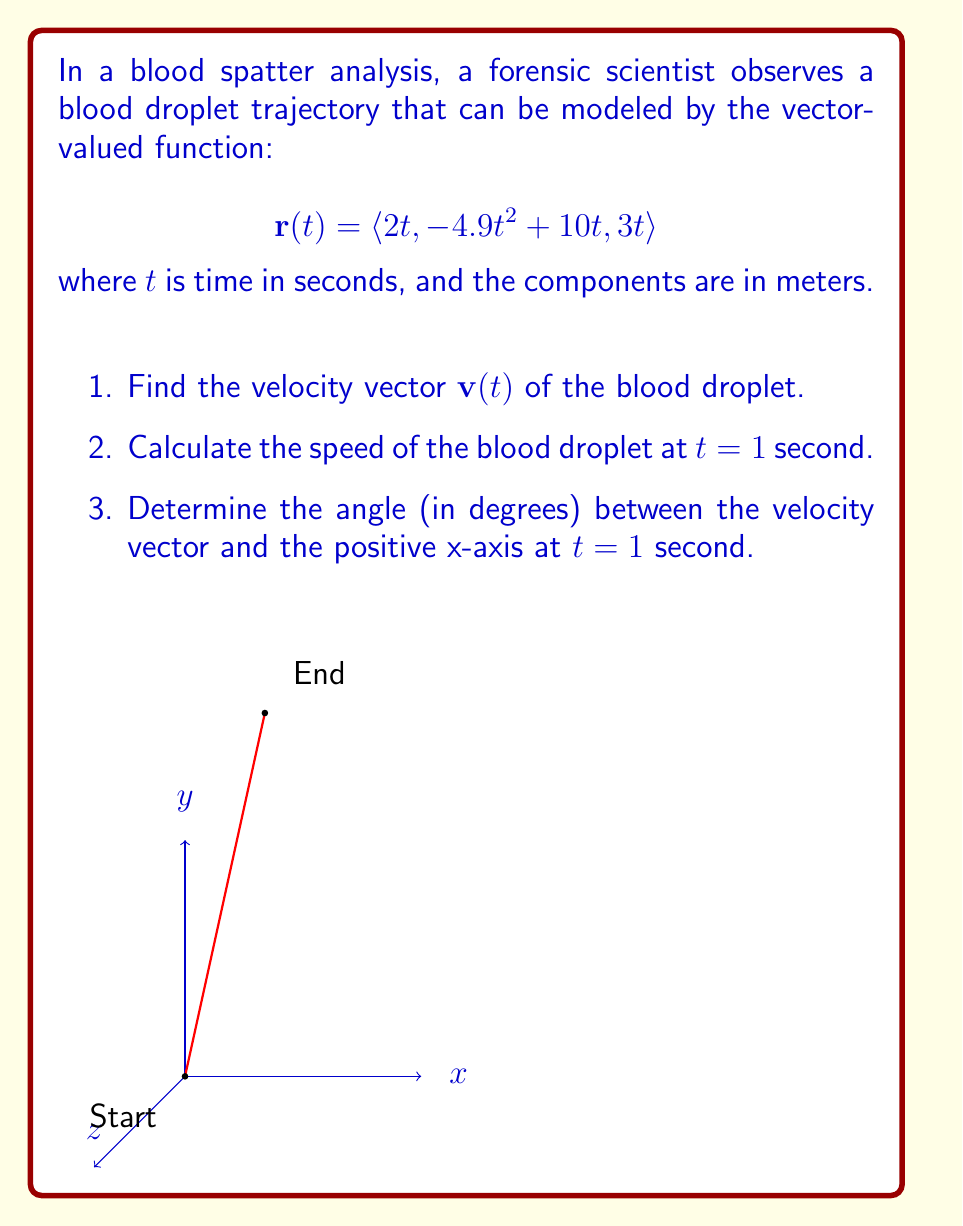What is the answer to this math problem? Let's approach this step-by-step:

1) To find the velocity vector $\mathbf{v}(t)$, we need to differentiate $\mathbf{r}(t)$ with respect to $t$:

   $$\mathbf{v}(t) = \frac{d}{dt}\mathbf{r}(t) = \langle \frac{d}{dt}(2t), \frac{d}{dt}(-4.9t^2 + 10t), \frac{d}{dt}(3t) \rangle$$
   
   $$\mathbf{v}(t) = \langle 2, -9.8t + 10, 3 \rangle$$

2) To calculate the speed at $t = 1$ second, we need to find the magnitude of the velocity vector at $t = 1$:

   $$\mathbf{v}(1) = \langle 2, -9.8 + 10, 3 \rangle = \langle 2, 0.2, 3 \rangle$$
   
   Speed = $\|\mathbf{v}(1)\| = \sqrt{2^2 + 0.2^2 + 3^2} = \sqrt{4 + 0.04 + 9} = \sqrt{13.04} \approx 3.61$ m/s

3) To find the angle between the velocity vector and the positive x-axis at $t = 1$, we can use the dot product formula:

   $$\cos \theta = \frac{\mathbf{v}(1) \cdot \mathbf{i}}{\|\mathbf{v}(1)\| \|\mathbf{i}\|}$$

   where $\mathbf{i} = \langle 1, 0, 0 \rangle$ is the unit vector in the x-direction.

   $$\cos \theta = \frac{2}{\sqrt{13.04}} \approx 0.5547$$

   $$\theta = \arccos(0.5547) \approx 0.9827 \text{ radians}$$

   Converting to degrees: $0.9827 \times \frac{180}{\pi} \approx 56.31°$
Answer: 1) $\mathbf{v}(t) = \langle 2, -9.8t + 10, 3 \rangle$
2) 3.61 m/s
3) 56.31° 